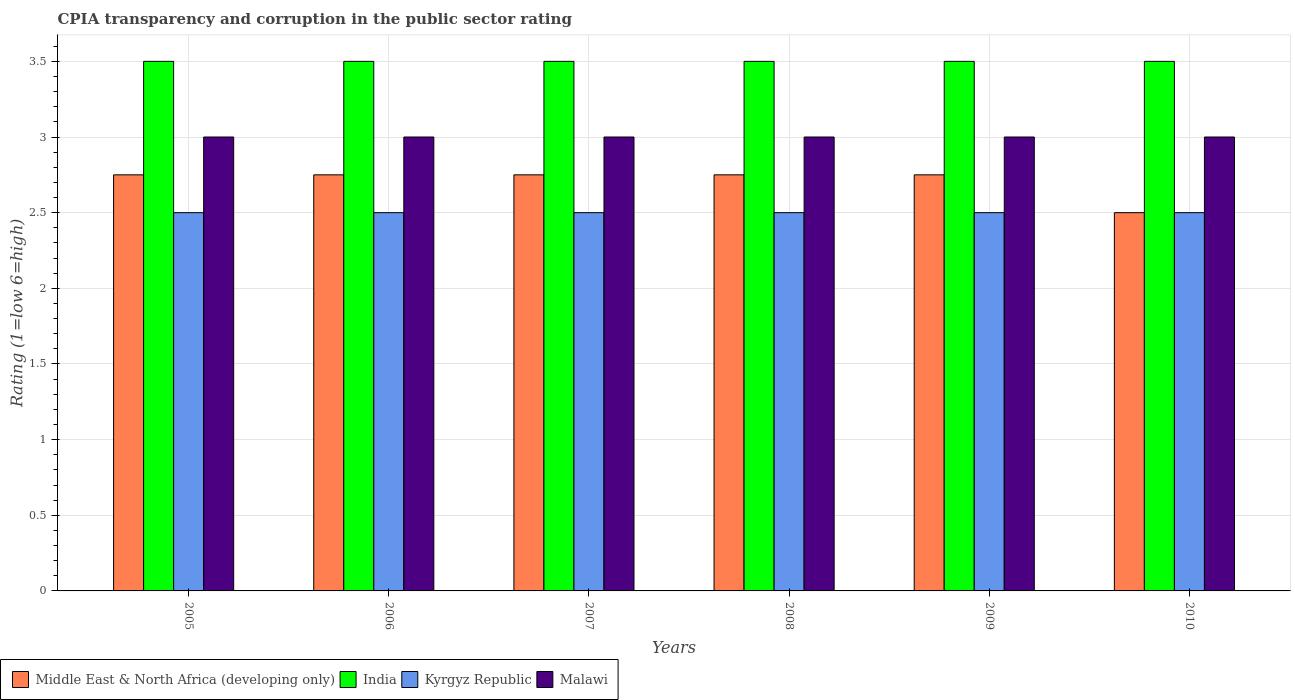How many different coloured bars are there?
Keep it short and to the point. 4. Are the number of bars per tick equal to the number of legend labels?
Make the answer very short. Yes. How many bars are there on the 5th tick from the right?
Offer a terse response. 4. What is the label of the 5th group of bars from the left?
Your answer should be very brief. 2009. In how many cases, is the number of bars for a given year not equal to the number of legend labels?
Offer a very short reply. 0. What is the CPIA rating in Malawi in 2010?
Offer a terse response. 3. Across all years, what is the minimum CPIA rating in India?
Provide a short and direct response. 3.5. In which year was the CPIA rating in India maximum?
Make the answer very short. 2005. In which year was the CPIA rating in Kyrgyz Republic minimum?
Ensure brevity in your answer.  2005. What is the total CPIA rating in Middle East & North Africa (developing only) in the graph?
Offer a very short reply. 16.25. What is the difference between the CPIA rating in India in 2006 and that in 2010?
Give a very brief answer. 0. What is the difference between the CPIA rating in India in 2007 and the CPIA rating in Kyrgyz Republic in 2005?
Make the answer very short. 1. What is the average CPIA rating in Kyrgyz Republic per year?
Keep it short and to the point. 2.5. What is the ratio of the CPIA rating in Middle East & North Africa (developing only) in 2009 to that in 2010?
Provide a succinct answer. 1.1. Is the CPIA rating in Kyrgyz Republic in 2007 less than that in 2009?
Give a very brief answer. No. What is the difference between the highest and the second highest CPIA rating in Kyrgyz Republic?
Give a very brief answer. 0. What is the difference between the highest and the lowest CPIA rating in India?
Give a very brief answer. 0. In how many years, is the CPIA rating in Kyrgyz Republic greater than the average CPIA rating in Kyrgyz Republic taken over all years?
Give a very brief answer. 0. What does the 4th bar from the left in 2006 represents?
Your answer should be compact. Malawi. What does the 2nd bar from the right in 2007 represents?
Make the answer very short. Kyrgyz Republic. How many bars are there?
Offer a very short reply. 24. Are all the bars in the graph horizontal?
Ensure brevity in your answer.  No. How many years are there in the graph?
Your answer should be very brief. 6. What is the difference between two consecutive major ticks on the Y-axis?
Your answer should be compact. 0.5. Are the values on the major ticks of Y-axis written in scientific E-notation?
Your response must be concise. No. Does the graph contain any zero values?
Your response must be concise. No. Where does the legend appear in the graph?
Keep it short and to the point. Bottom left. How are the legend labels stacked?
Provide a short and direct response. Horizontal. What is the title of the graph?
Your answer should be compact. CPIA transparency and corruption in the public sector rating. Does "Somalia" appear as one of the legend labels in the graph?
Provide a short and direct response. No. What is the label or title of the Y-axis?
Offer a very short reply. Rating (1=low 6=high). What is the Rating (1=low 6=high) of Middle East & North Africa (developing only) in 2005?
Provide a short and direct response. 2.75. What is the Rating (1=low 6=high) of India in 2005?
Your response must be concise. 3.5. What is the Rating (1=low 6=high) of Middle East & North Africa (developing only) in 2006?
Offer a very short reply. 2.75. What is the Rating (1=low 6=high) of Kyrgyz Republic in 2006?
Offer a very short reply. 2.5. What is the Rating (1=low 6=high) in Middle East & North Africa (developing only) in 2007?
Offer a very short reply. 2.75. What is the Rating (1=low 6=high) in India in 2007?
Your answer should be very brief. 3.5. What is the Rating (1=low 6=high) in Malawi in 2007?
Make the answer very short. 3. What is the Rating (1=low 6=high) of Middle East & North Africa (developing only) in 2008?
Offer a very short reply. 2.75. What is the Rating (1=low 6=high) in Kyrgyz Republic in 2008?
Make the answer very short. 2.5. What is the Rating (1=low 6=high) in Malawi in 2008?
Provide a short and direct response. 3. What is the Rating (1=low 6=high) in Middle East & North Africa (developing only) in 2009?
Offer a terse response. 2.75. What is the Rating (1=low 6=high) of Kyrgyz Republic in 2009?
Make the answer very short. 2.5. What is the Rating (1=low 6=high) of Middle East & North Africa (developing only) in 2010?
Provide a short and direct response. 2.5. What is the Rating (1=low 6=high) in India in 2010?
Keep it short and to the point. 3.5. Across all years, what is the maximum Rating (1=low 6=high) of Middle East & North Africa (developing only)?
Provide a short and direct response. 2.75. Across all years, what is the maximum Rating (1=low 6=high) of Kyrgyz Republic?
Make the answer very short. 2.5. Across all years, what is the maximum Rating (1=low 6=high) of Malawi?
Provide a short and direct response. 3. Across all years, what is the minimum Rating (1=low 6=high) in Middle East & North Africa (developing only)?
Offer a very short reply. 2.5. Across all years, what is the minimum Rating (1=low 6=high) of India?
Offer a terse response. 3.5. Across all years, what is the minimum Rating (1=low 6=high) in Kyrgyz Republic?
Your answer should be compact. 2.5. Across all years, what is the minimum Rating (1=low 6=high) in Malawi?
Offer a terse response. 3. What is the total Rating (1=low 6=high) in Middle East & North Africa (developing only) in the graph?
Your answer should be compact. 16.25. What is the total Rating (1=low 6=high) of India in the graph?
Offer a very short reply. 21. What is the total Rating (1=low 6=high) in Kyrgyz Republic in the graph?
Keep it short and to the point. 15. What is the total Rating (1=low 6=high) in Malawi in the graph?
Make the answer very short. 18. What is the difference between the Rating (1=low 6=high) in Middle East & North Africa (developing only) in 2005 and that in 2006?
Offer a terse response. 0. What is the difference between the Rating (1=low 6=high) of India in 2005 and that in 2006?
Offer a terse response. 0. What is the difference between the Rating (1=low 6=high) in Kyrgyz Republic in 2005 and that in 2006?
Make the answer very short. 0. What is the difference between the Rating (1=low 6=high) in Malawi in 2005 and that in 2006?
Your answer should be very brief. 0. What is the difference between the Rating (1=low 6=high) in Malawi in 2005 and that in 2007?
Offer a terse response. 0. What is the difference between the Rating (1=low 6=high) in Middle East & North Africa (developing only) in 2005 and that in 2008?
Keep it short and to the point. 0. What is the difference between the Rating (1=low 6=high) in India in 2005 and that in 2008?
Ensure brevity in your answer.  0. What is the difference between the Rating (1=low 6=high) in Kyrgyz Republic in 2005 and that in 2008?
Provide a succinct answer. 0. What is the difference between the Rating (1=low 6=high) of Middle East & North Africa (developing only) in 2005 and that in 2009?
Your response must be concise. 0. What is the difference between the Rating (1=low 6=high) of Kyrgyz Republic in 2005 and that in 2009?
Provide a succinct answer. 0. What is the difference between the Rating (1=low 6=high) in Middle East & North Africa (developing only) in 2005 and that in 2010?
Ensure brevity in your answer.  0.25. What is the difference between the Rating (1=low 6=high) in India in 2006 and that in 2007?
Make the answer very short. 0. What is the difference between the Rating (1=low 6=high) of Kyrgyz Republic in 2006 and that in 2007?
Keep it short and to the point. 0. What is the difference between the Rating (1=low 6=high) of Middle East & North Africa (developing only) in 2006 and that in 2008?
Provide a short and direct response. 0. What is the difference between the Rating (1=low 6=high) of India in 2006 and that in 2008?
Provide a short and direct response. 0. What is the difference between the Rating (1=low 6=high) in Middle East & North Africa (developing only) in 2006 and that in 2009?
Your answer should be compact. 0. What is the difference between the Rating (1=low 6=high) in Kyrgyz Republic in 2006 and that in 2009?
Your answer should be very brief. 0. What is the difference between the Rating (1=low 6=high) of Malawi in 2006 and that in 2009?
Ensure brevity in your answer.  0. What is the difference between the Rating (1=low 6=high) in Malawi in 2006 and that in 2010?
Provide a short and direct response. 0. What is the difference between the Rating (1=low 6=high) of India in 2007 and that in 2008?
Give a very brief answer. 0. What is the difference between the Rating (1=low 6=high) in Kyrgyz Republic in 2007 and that in 2008?
Your answer should be compact. 0. What is the difference between the Rating (1=low 6=high) in Middle East & North Africa (developing only) in 2007 and that in 2010?
Provide a short and direct response. 0.25. What is the difference between the Rating (1=low 6=high) in India in 2007 and that in 2010?
Your answer should be very brief. 0. What is the difference between the Rating (1=low 6=high) of Kyrgyz Republic in 2007 and that in 2010?
Ensure brevity in your answer.  0. What is the difference between the Rating (1=low 6=high) in Middle East & North Africa (developing only) in 2008 and that in 2009?
Give a very brief answer. 0. What is the difference between the Rating (1=low 6=high) of Malawi in 2008 and that in 2009?
Offer a very short reply. 0. What is the difference between the Rating (1=low 6=high) in Malawi in 2008 and that in 2010?
Offer a terse response. 0. What is the difference between the Rating (1=low 6=high) of Middle East & North Africa (developing only) in 2009 and that in 2010?
Offer a terse response. 0.25. What is the difference between the Rating (1=low 6=high) of India in 2009 and that in 2010?
Your response must be concise. 0. What is the difference between the Rating (1=low 6=high) in Middle East & North Africa (developing only) in 2005 and the Rating (1=low 6=high) in India in 2006?
Your response must be concise. -0.75. What is the difference between the Rating (1=low 6=high) in Middle East & North Africa (developing only) in 2005 and the Rating (1=low 6=high) in Malawi in 2006?
Make the answer very short. -0.25. What is the difference between the Rating (1=low 6=high) of India in 2005 and the Rating (1=low 6=high) of Malawi in 2006?
Your answer should be very brief. 0.5. What is the difference between the Rating (1=low 6=high) of Kyrgyz Republic in 2005 and the Rating (1=low 6=high) of Malawi in 2006?
Ensure brevity in your answer.  -0.5. What is the difference between the Rating (1=low 6=high) of Middle East & North Africa (developing only) in 2005 and the Rating (1=low 6=high) of India in 2007?
Ensure brevity in your answer.  -0.75. What is the difference between the Rating (1=low 6=high) of Middle East & North Africa (developing only) in 2005 and the Rating (1=low 6=high) of Kyrgyz Republic in 2007?
Make the answer very short. 0.25. What is the difference between the Rating (1=low 6=high) of India in 2005 and the Rating (1=low 6=high) of Kyrgyz Republic in 2007?
Your answer should be very brief. 1. What is the difference between the Rating (1=low 6=high) in Kyrgyz Republic in 2005 and the Rating (1=low 6=high) in Malawi in 2007?
Give a very brief answer. -0.5. What is the difference between the Rating (1=low 6=high) of Middle East & North Africa (developing only) in 2005 and the Rating (1=low 6=high) of India in 2008?
Your answer should be very brief. -0.75. What is the difference between the Rating (1=low 6=high) in Middle East & North Africa (developing only) in 2005 and the Rating (1=low 6=high) in Kyrgyz Republic in 2008?
Offer a very short reply. 0.25. What is the difference between the Rating (1=low 6=high) in Middle East & North Africa (developing only) in 2005 and the Rating (1=low 6=high) in Malawi in 2008?
Your response must be concise. -0.25. What is the difference between the Rating (1=low 6=high) in India in 2005 and the Rating (1=low 6=high) in Kyrgyz Republic in 2008?
Provide a succinct answer. 1. What is the difference between the Rating (1=low 6=high) of India in 2005 and the Rating (1=low 6=high) of Malawi in 2008?
Provide a short and direct response. 0.5. What is the difference between the Rating (1=low 6=high) of Kyrgyz Republic in 2005 and the Rating (1=low 6=high) of Malawi in 2008?
Offer a terse response. -0.5. What is the difference between the Rating (1=low 6=high) of Middle East & North Africa (developing only) in 2005 and the Rating (1=low 6=high) of India in 2009?
Provide a short and direct response. -0.75. What is the difference between the Rating (1=low 6=high) in Middle East & North Africa (developing only) in 2005 and the Rating (1=low 6=high) in Kyrgyz Republic in 2009?
Provide a succinct answer. 0.25. What is the difference between the Rating (1=low 6=high) of Middle East & North Africa (developing only) in 2005 and the Rating (1=low 6=high) of Malawi in 2009?
Provide a succinct answer. -0.25. What is the difference between the Rating (1=low 6=high) in India in 2005 and the Rating (1=low 6=high) in Kyrgyz Republic in 2009?
Make the answer very short. 1. What is the difference between the Rating (1=low 6=high) in Middle East & North Africa (developing only) in 2005 and the Rating (1=low 6=high) in India in 2010?
Offer a very short reply. -0.75. What is the difference between the Rating (1=low 6=high) in India in 2005 and the Rating (1=low 6=high) in Malawi in 2010?
Ensure brevity in your answer.  0.5. What is the difference between the Rating (1=low 6=high) of Middle East & North Africa (developing only) in 2006 and the Rating (1=low 6=high) of India in 2007?
Keep it short and to the point. -0.75. What is the difference between the Rating (1=low 6=high) in Middle East & North Africa (developing only) in 2006 and the Rating (1=low 6=high) in Kyrgyz Republic in 2007?
Provide a short and direct response. 0.25. What is the difference between the Rating (1=low 6=high) of India in 2006 and the Rating (1=low 6=high) of Kyrgyz Republic in 2007?
Provide a succinct answer. 1. What is the difference between the Rating (1=low 6=high) in India in 2006 and the Rating (1=low 6=high) in Malawi in 2007?
Your answer should be compact. 0.5. What is the difference between the Rating (1=low 6=high) in Middle East & North Africa (developing only) in 2006 and the Rating (1=low 6=high) in India in 2008?
Provide a succinct answer. -0.75. What is the difference between the Rating (1=low 6=high) in Middle East & North Africa (developing only) in 2006 and the Rating (1=low 6=high) in Malawi in 2008?
Make the answer very short. -0.25. What is the difference between the Rating (1=low 6=high) in India in 2006 and the Rating (1=low 6=high) in Kyrgyz Republic in 2008?
Your response must be concise. 1. What is the difference between the Rating (1=low 6=high) in India in 2006 and the Rating (1=low 6=high) in Malawi in 2008?
Your response must be concise. 0.5. What is the difference between the Rating (1=low 6=high) of Kyrgyz Republic in 2006 and the Rating (1=low 6=high) of Malawi in 2008?
Give a very brief answer. -0.5. What is the difference between the Rating (1=low 6=high) of Middle East & North Africa (developing only) in 2006 and the Rating (1=low 6=high) of India in 2009?
Provide a succinct answer. -0.75. What is the difference between the Rating (1=low 6=high) of Middle East & North Africa (developing only) in 2006 and the Rating (1=low 6=high) of Kyrgyz Republic in 2009?
Provide a short and direct response. 0.25. What is the difference between the Rating (1=low 6=high) in Middle East & North Africa (developing only) in 2006 and the Rating (1=low 6=high) in Malawi in 2009?
Your answer should be very brief. -0.25. What is the difference between the Rating (1=low 6=high) of India in 2006 and the Rating (1=low 6=high) of Kyrgyz Republic in 2009?
Make the answer very short. 1. What is the difference between the Rating (1=low 6=high) in Middle East & North Africa (developing only) in 2006 and the Rating (1=low 6=high) in India in 2010?
Provide a short and direct response. -0.75. What is the difference between the Rating (1=low 6=high) in India in 2006 and the Rating (1=low 6=high) in Kyrgyz Republic in 2010?
Offer a terse response. 1. What is the difference between the Rating (1=low 6=high) in Middle East & North Africa (developing only) in 2007 and the Rating (1=low 6=high) in India in 2008?
Ensure brevity in your answer.  -0.75. What is the difference between the Rating (1=low 6=high) in Middle East & North Africa (developing only) in 2007 and the Rating (1=low 6=high) in Kyrgyz Republic in 2008?
Give a very brief answer. 0.25. What is the difference between the Rating (1=low 6=high) of India in 2007 and the Rating (1=low 6=high) of Kyrgyz Republic in 2008?
Offer a very short reply. 1. What is the difference between the Rating (1=low 6=high) of Middle East & North Africa (developing only) in 2007 and the Rating (1=low 6=high) of India in 2009?
Your response must be concise. -0.75. What is the difference between the Rating (1=low 6=high) in India in 2007 and the Rating (1=low 6=high) in Kyrgyz Republic in 2009?
Your response must be concise. 1. What is the difference between the Rating (1=low 6=high) of India in 2007 and the Rating (1=low 6=high) of Malawi in 2009?
Offer a terse response. 0.5. What is the difference between the Rating (1=low 6=high) of Middle East & North Africa (developing only) in 2007 and the Rating (1=low 6=high) of India in 2010?
Your answer should be very brief. -0.75. What is the difference between the Rating (1=low 6=high) in Middle East & North Africa (developing only) in 2007 and the Rating (1=low 6=high) in Kyrgyz Republic in 2010?
Make the answer very short. 0.25. What is the difference between the Rating (1=low 6=high) of India in 2007 and the Rating (1=low 6=high) of Kyrgyz Republic in 2010?
Ensure brevity in your answer.  1. What is the difference between the Rating (1=low 6=high) in Middle East & North Africa (developing only) in 2008 and the Rating (1=low 6=high) in India in 2009?
Make the answer very short. -0.75. What is the difference between the Rating (1=low 6=high) in Middle East & North Africa (developing only) in 2008 and the Rating (1=low 6=high) in Malawi in 2009?
Offer a terse response. -0.25. What is the difference between the Rating (1=low 6=high) in India in 2008 and the Rating (1=low 6=high) in Kyrgyz Republic in 2009?
Make the answer very short. 1. What is the difference between the Rating (1=low 6=high) of India in 2008 and the Rating (1=low 6=high) of Malawi in 2009?
Ensure brevity in your answer.  0.5. What is the difference between the Rating (1=low 6=high) in Middle East & North Africa (developing only) in 2008 and the Rating (1=low 6=high) in India in 2010?
Your answer should be very brief. -0.75. What is the difference between the Rating (1=low 6=high) in Middle East & North Africa (developing only) in 2008 and the Rating (1=low 6=high) in Malawi in 2010?
Give a very brief answer. -0.25. What is the difference between the Rating (1=low 6=high) in India in 2008 and the Rating (1=low 6=high) in Kyrgyz Republic in 2010?
Your response must be concise. 1. What is the difference between the Rating (1=low 6=high) in India in 2008 and the Rating (1=low 6=high) in Malawi in 2010?
Make the answer very short. 0.5. What is the difference between the Rating (1=low 6=high) in Middle East & North Africa (developing only) in 2009 and the Rating (1=low 6=high) in India in 2010?
Your response must be concise. -0.75. What is the difference between the Rating (1=low 6=high) of Middle East & North Africa (developing only) in 2009 and the Rating (1=low 6=high) of Malawi in 2010?
Your response must be concise. -0.25. What is the difference between the Rating (1=low 6=high) in India in 2009 and the Rating (1=low 6=high) in Malawi in 2010?
Your answer should be very brief. 0.5. What is the difference between the Rating (1=low 6=high) of Kyrgyz Republic in 2009 and the Rating (1=low 6=high) of Malawi in 2010?
Provide a succinct answer. -0.5. What is the average Rating (1=low 6=high) in Middle East & North Africa (developing only) per year?
Your answer should be very brief. 2.71. What is the average Rating (1=low 6=high) of Kyrgyz Republic per year?
Your answer should be very brief. 2.5. In the year 2005, what is the difference between the Rating (1=low 6=high) in Middle East & North Africa (developing only) and Rating (1=low 6=high) in India?
Ensure brevity in your answer.  -0.75. In the year 2005, what is the difference between the Rating (1=low 6=high) of Middle East & North Africa (developing only) and Rating (1=low 6=high) of Kyrgyz Republic?
Provide a succinct answer. 0.25. In the year 2005, what is the difference between the Rating (1=low 6=high) in India and Rating (1=low 6=high) in Kyrgyz Republic?
Your answer should be compact. 1. In the year 2006, what is the difference between the Rating (1=low 6=high) in Middle East & North Africa (developing only) and Rating (1=low 6=high) in India?
Ensure brevity in your answer.  -0.75. In the year 2006, what is the difference between the Rating (1=low 6=high) of Middle East & North Africa (developing only) and Rating (1=low 6=high) of Kyrgyz Republic?
Offer a very short reply. 0.25. In the year 2006, what is the difference between the Rating (1=low 6=high) in Middle East & North Africa (developing only) and Rating (1=low 6=high) in Malawi?
Make the answer very short. -0.25. In the year 2006, what is the difference between the Rating (1=low 6=high) of India and Rating (1=low 6=high) of Kyrgyz Republic?
Keep it short and to the point. 1. In the year 2006, what is the difference between the Rating (1=low 6=high) of Kyrgyz Republic and Rating (1=low 6=high) of Malawi?
Make the answer very short. -0.5. In the year 2007, what is the difference between the Rating (1=low 6=high) of Middle East & North Africa (developing only) and Rating (1=low 6=high) of India?
Provide a short and direct response. -0.75. In the year 2007, what is the difference between the Rating (1=low 6=high) in Middle East & North Africa (developing only) and Rating (1=low 6=high) in Kyrgyz Republic?
Provide a short and direct response. 0.25. In the year 2007, what is the difference between the Rating (1=low 6=high) in Middle East & North Africa (developing only) and Rating (1=low 6=high) in Malawi?
Ensure brevity in your answer.  -0.25. In the year 2007, what is the difference between the Rating (1=low 6=high) in India and Rating (1=low 6=high) in Kyrgyz Republic?
Your response must be concise. 1. In the year 2008, what is the difference between the Rating (1=low 6=high) of Middle East & North Africa (developing only) and Rating (1=low 6=high) of India?
Your answer should be very brief. -0.75. In the year 2008, what is the difference between the Rating (1=low 6=high) of Middle East & North Africa (developing only) and Rating (1=low 6=high) of Kyrgyz Republic?
Your response must be concise. 0.25. In the year 2008, what is the difference between the Rating (1=low 6=high) in Kyrgyz Republic and Rating (1=low 6=high) in Malawi?
Give a very brief answer. -0.5. In the year 2009, what is the difference between the Rating (1=low 6=high) in Middle East & North Africa (developing only) and Rating (1=low 6=high) in India?
Your answer should be very brief. -0.75. In the year 2009, what is the difference between the Rating (1=low 6=high) of Middle East & North Africa (developing only) and Rating (1=low 6=high) of Kyrgyz Republic?
Provide a short and direct response. 0.25. In the year 2009, what is the difference between the Rating (1=low 6=high) in India and Rating (1=low 6=high) in Kyrgyz Republic?
Offer a very short reply. 1. In the year 2009, what is the difference between the Rating (1=low 6=high) of Kyrgyz Republic and Rating (1=low 6=high) of Malawi?
Provide a succinct answer. -0.5. In the year 2010, what is the difference between the Rating (1=low 6=high) in Middle East & North Africa (developing only) and Rating (1=low 6=high) in Kyrgyz Republic?
Your answer should be very brief. 0. In the year 2010, what is the difference between the Rating (1=low 6=high) in India and Rating (1=low 6=high) in Kyrgyz Republic?
Your answer should be compact. 1. In the year 2010, what is the difference between the Rating (1=low 6=high) of India and Rating (1=low 6=high) of Malawi?
Give a very brief answer. 0.5. What is the ratio of the Rating (1=low 6=high) in Kyrgyz Republic in 2005 to that in 2006?
Make the answer very short. 1. What is the ratio of the Rating (1=low 6=high) in Middle East & North Africa (developing only) in 2005 to that in 2007?
Provide a short and direct response. 1. What is the ratio of the Rating (1=low 6=high) in India in 2005 to that in 2007?
Give a very brief answer. 1. What is the ratio of the Rating (1=low 6=high) in Kyrgyz Republic in 2005 to that in 2007?
Your response must be concise. 1. What is the ratio of the Rating (1=low 6=high) in Malawi in 2005 to that in 2007?
Offer a very short reply. 1. What is the ratio of the Rating (1=low 6=high) of Middle East & North Africa (developing only) in 2005 to that in 2008?
Ensure brevity in your answer.  1. What is the ratio of the Rating (1=low 6=high) in Malawi in 2005 to that in 2008?
Give a very brief answer. 1. What is the ratio of the Rating (1=low 6=high) in India in 2005 to that in 2009?
Give a very brief answer. 1. What is the ratio of the Rating (1=low 6=high) of Malawi in 2005 to that in 2009?
Provide a short and direct response. 1. What is the ratio of the Rating (1=low 6=high) in India in 2005 to that in 2010?
Provide a succinct answer. 1. What is the ratio of the Rating (1=low 6=high) of Middle East & North Africa (developing only) in 2006 to that in 2007?
Keep it short and to the point. 1. What is the ratio of the Rating (1=low 6=high) of India in 2006 to that in 2007?
Your response must be concise. 1. What is the ratio of the Rating (1=low 6=high) of Middle East & North Africa (developing only) in 2006 to that in 2008?
Offer a terse response. 1. What is the ratio of the Rating (1=low 6=high) in India in 2006 to that in 2008?
Offer a terse response. 1. What is the ratio of the Rating (1=low 6=high) in Kyrgyz Republic in 2006 to that in 2008?
Offer a terse response. 1. What is the ratio of the Rating (1=low 6=high) of Middle East & North Africa (developing only) in 2006 to that in 2009?
Your answer should be compact. 1. What is the ratio of the Rating (1=low 6=high) of Malawi in 2006 to that in 2009?
Make the answer very short. 1. What is the ratio of the Rating (1=low 6=high) of Middle East & North Africa (developing only) in 2006 to that in 2010?
Offer a terse response. 1.1. What is the ratio of the Rating (1=low 6=high) in Malawi in 2006 to that in 2010?
Offer a very short reply. 1. What is the ratio of the Rating (1=low 6=high) of Malawi in 2007 to that in 2008?
Your response must be concise. 1. What is the ratio of the Rating (1=low 6=high) in India in 2007 to that in 2010?
Your answer should be very brief. 1. What is the ratio of the Rating (1=low 6=high) of Kyrgyz Republic in 2007 to that in 2010?
Provide a short and direct response. 1. What is the ratio of the Rating (1=low 6=high) in India in 2008 to that in 2009?
Give a very brief answer. 1. What is the ratio of the Rating (1=low 6=high) of Kyrgyz Republic in 2008 to that in 2009?
Your response must be concise. 1. What is the ratio of the Rating (1=low 6=high) in Kyrgyz Republic in 2008 to that in 2010?
Your answer should be compact. 1. What is the ratio of the Rating (1=low 6=high) in Malawi in 2008 to that in 2010?
Provide a succinct answer. 1. What is the ratio of the Rating (1=low 6=high) in Middle East & North Africa (developing only) in 2009 to that in 2010?
Your response must be concise. 1.1. What is the ratio of the Rating (1=low 6=high) in Malawi in 2009 to that in 2010?
Offer a terse response. 1. What is the difference between the highest and the second highest Rating (1=low 6=high) of Middle East & North Africa (developing only)?
Ensure brevity in your answer.  0. What is the difference between the highest and the second highest Rating (1=low 6=high) of India?
Your answer should be very brief. 0. What is the difference between the highest and the second highest Rating (1=low 6=high) in Malawi?
Keep it short and to the point. 0. 